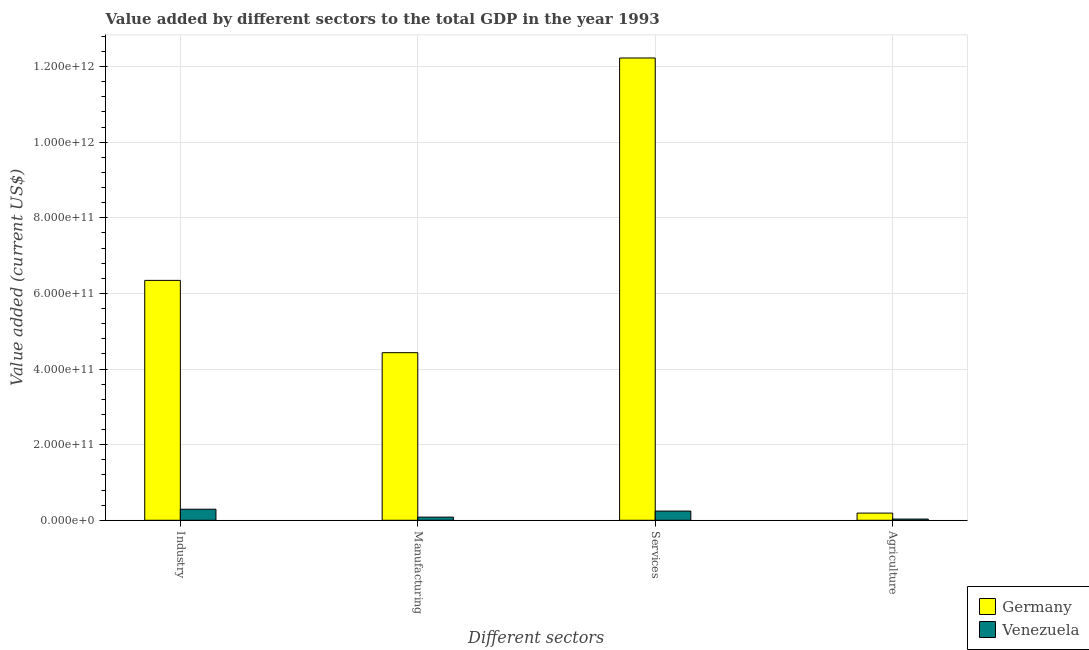How many bars are there on the 3rd tick from the left?
Ensure brevity in your answer.  2. What is the label of the 3rd group of bars from the left?
Offer a very short reply. Services. What is the value added by industrial sector in Germany?
Provide a short and direct response. 6.35e+11. Across all countries, what is the maximum value added by manufacturing sector?
Provide a short and direct response. 4.43e+11. Across all countries, what is the minimum value added by manufacturing sector?
Your response must be concise. 8.33e+09. In which country was the value added by manufacturing sector minimum?
Ensure brevity in your answer.  Venezuela. What is the total value added by industrial sector in the graph?
Your answer should be very brief. 6.64e+11. What is the difference between the value added by manufacturing sector in Germany and that in Venezuela?
Your answer should be compact. 4.35e+11. What is the difference between the value added by services sector in Germany and the value added by industrial sector in Venezuela?
Provide a succinct answer. 1.19e+12. What is the average value added by manufacturing sector per country?
Your response must be concise. 2.26e+11. What is the difference between the value added by industrial sector and value added by manufacturing sector in Germany?
Make the answer very short. 1.91e+11. What is the ratio of the value added by agricultural sector in Germany to that in Venezuela?
Your response must be concise. 6.1. Is the value added by industrial sector in Germany less than that in Venezuela?
Your answer should be compact. No. Is the difference between the value added by agricultural sector in Venezuela and Germany greater than the difference between the value added by services sector in Venezuela and Germany?
Keep it short and to the point. Yes. What is the difference between the highest and the second highest value added by industrial sector?
Your answer should be compact. 6.05e+11. What is the difference between the highest and the lowest value added by industrial sector?
Offer a terse response. 6.05e+11. Is the sum of the value added by services sector in Venezuela and Germany greater than the maximum value added by agricultural sector across all countries?
Make the answer very short. Yes. What does the 2nd bar from the left in Agriculture represents?
Keep it short and to the point. Venezuela. What does the 1st bar from the right in Manufacturing represents?
Give a very brief answer. Venezuela. Is it the case that in every country, the sum of the value added by industrial sector and value added by manufacturing sector is greater than the value added by services sector?
Make the answer very short. No. Are all the bars in the graph horizontal?
Keep it short and to the point. No. How many countries are there in the graph?
Keep it short and to the point. 2. What is the difference between two consecutive major ticks on the Y-axis?
Provide a succinct answer. 2.00e+11. Are the values on the major ticks of Y-axis written in scientific E-notation?
Ensure brevity in your answer.  Yes. How many legend labels are there?
Keep it short and to the point. 2. How are the legend labels stacked?
Provide a short and direct response. Vertical. What is the title of the graph?
Your answer should be very brief. Value added by different sectors to the total GDP in the year 1993. What is the label or title of the X-axis?
Give a very brief answer. Different sectors. What is the label or title of the Y-axis?
Make the answer very short. Value added (current US$). What is the Value added (current US$) in Germany in Industry?
Give a very brief answer. 6.35e+11. What is the Value added (current US$) of Venezuela in Industry?
Make the answer very short. 2.92e+1. What is the Value added (current US$) in Germany in Manufacturing?
Ensure brevity in your answer.  4.43e+11. What is the Value added (current US$) of Venezuela in Manufacturing?
Make the answer very short. 8.33e+09. What is the Value added (current US$) in Germany in Services?
Ensure brevity in your answer.  1.22e+12. What is the Value added (current US$) of Venezuela in Services?
Your answer should be very brief. 2.43e+1. What is the Value added (current US$) in Germany in Agriculture?
Your response must be concise. 1.90e+1. What is the Value added (current US$) of Venezuela in Agriculture?
Provide a short and direct response. 3.11e+09. Across all Different sectors, what is the maximum Value added (current US$) in Germany?
Ensure brevity in your answer.  1.22e+12. Across all Different sectors, what is the maximum Value added (current US$) of Venezuela?
Ensure brevity in your answer.  2.92e+1. Across all Different sectors, what is the minimum Value added (current US$) of Germany?
Keep it short and to the point. 1.90e+1. Across all Different sectors, what is the minimum Value added (current US$) in Venezuela?
Your answer should be compact. 3.11e+09. What is the total Value added (current US$) in Germany in the graph?
Ensure brevity in your answer.  2.32e+12. What is the total Value added (current US$) of Venezuela in the graph?
Keep it short and to the point. 6.50e+1. What is the difference between the Value added (current US$) in Germany in Industry and that in Manufacturing?
Keep it short and to the point. 1.91e+11. What is the difference between the Value added (current US$) in Venezuela in Industry and that in Manufacturing?
Your response must be concise. 2.09e+1. What is the difference between the Value added (current US$) of Germany in Industry and that in Services?
Provide a succinct answer. -5.88e+11. What is the difference between the Value added (current US$) of Venezuela in Industry and that in Services?
Your answer should be compact. 4.90e+09. What is the difference between the Value added (current US$) of Germany in Industry and that in Agriculture?
Your answer should be compact. 6.16e+11. What is the difference between the Value added (current US$) in Venezuela in Industry and that in Agriculture?
Offer a very short reply. 2.61e+1. What is the difference between the Value added (current US$) of Germany in Manufacturing and that in Services?
Offer a very short reply. -7.80e+11. What is the difference between the Value added (current US$) of Venezuela in Manufacturing and that in Services?
Your answer should be compact. -1.60e+1. What is the difference between the Value added (current US$) of Germany in Manufacturing and that in Agriculture?
Your answer should be compact. 4.24e+11. What is the difference between the Value added (current US$) of Venezuela in Manufacturing and that in Agriculture?
Give a very brief answer. 5.22e+09. What is the difference between the Value added (current US$) in Germany in Services and that in Agriculture?
Your response must be concise. 1.20e+12. What is the difference between the Value added (current US$) of Venezuela in Services and that in Agriculture?
Your answer should be very brief. 2.12e+1. What is the difference between the Value added (current US$) in Germany in Industry and the Value added (current US$) in Venezuela in Manufacturing?
Offer a terse response. 6.26e+11. What is the difference between the Value added (current US$) of Germany in Industry and the Value added (current US$) of Venezuela in Services?
Give a very brief answer. 6.10e+11. What is the difference between the Value added (current US$) in Germany in Industry and the Value added (current US$) in Venezuela in Agriculture?
Ensure brevity in your answer.  6.31e+11. What is the difference between the Value added (current US$) of Germany in Manufacturing and the Value added (current US$) of Venezuela in Services?
Offer a very short reply. 4.19e+11. What is the difference between the Value added (current US$) in Germany in Manufacturing and the Value added (current US$) in Venezuela in Agriculture?
Offer a very short reply. 4.40e+11. What is the difference between the Value added (current US$) in Germany in Services and the Value added (current US$) in Venezuela in Agriculture?
Give a very brief answer. 1.22e+12. What is the average Value added (current US$) in Germany per Different sectors?
Your answer should be very brief. 5.80e+11. What is the average Value added (current US$) in Venezuela per Different sectors?
Your response must be concise. 1.62e+1. What is the difference between the Value added (current US$) in Germany and Value added (current US$) in Venezuela in Industry?
Your answer should be very brief. 6.05e+11. What is the difference between the Value added (current US$) in Germany and Value added (current US$) in Venezuela in Manufacturing?
Offer a very short reply. 4.35e+11. What is the difference between the Value added (current US$) of Germany and Value added (current US$) of Venezuela in Services?
Your answer should be very brief. 1.20e+12. What is the difference between the Value added (current US$) in Germany and Value added (current US$) in Venezuela in Agriculture?
Offer a terse response. 1.58e+1. What is the ratio of the Value added (current US$) of Germany in Industry to that in Manufacturing?
Keep it short and to the point. 1.43. What is the ratio of the Value added (current US$) of Venezuela in Industry to that in Manufacturing?
Make the answer very short. 3.51. What is the ratio of the Value added (current US$) in Germany in Industry to that in Services?
Provide a succinct answer. 0.52. What is the ratio of the Value added (current US$) of Venezuela in Industry to that in Services?
Your response must be concise. 1.2. What is the ratio of the Value added (current US$) of Germany in Industry to that in Agriculture?
Keep it short and to the point. 33.48. What is the ratio of the Value added (current US$) in Venezuela in Industry to that in Agriculture?
Offer a very short reply. 9.4. What is the ratio of the Value added (current US$) in Germany in Manufacturing to that in Services?
Provide a short and direct response. 0.36. What is the ratio of the Value added (current US$) in Venezuela in Manufacturing to that in Services?
Your answer should be compact. 0.34. What is the ratio of the Value added (current US$) of Germany in Manufacturing to that in Agriculture?
Provide a short and direct response. 23.39. What is the ratio of the Value added (current US$) in Venezuela in Manufacturing to that in Agriculture?
Give a very brief answer. 2.68. What is the ratio of the Value added (current US$) of Germany in Services to that in Agriculture?
Provide a short and direct response. 64.52. What is the ratio of the Value added (current US$) in Venezuela in Services to that in Agriculture?
Your answer should be very brief. 7.82. What is the difference between the highest and the second highest Value added (current US$) of Germany?
Provide a succinct answer. 5.88e+11. What is the difference between the highest and the second highest Value added (current US$) in Venezuela?
Make the answer very short. 4.90e+09. What is the difference between the highest and the lowest Value added (current US$) of Germany?
Your response must be concise. 1.20e+12. What is the difference between the highest and the lowest Value added (current US$) in Venezuela?
Offer a terse response. 2.61e+1. 